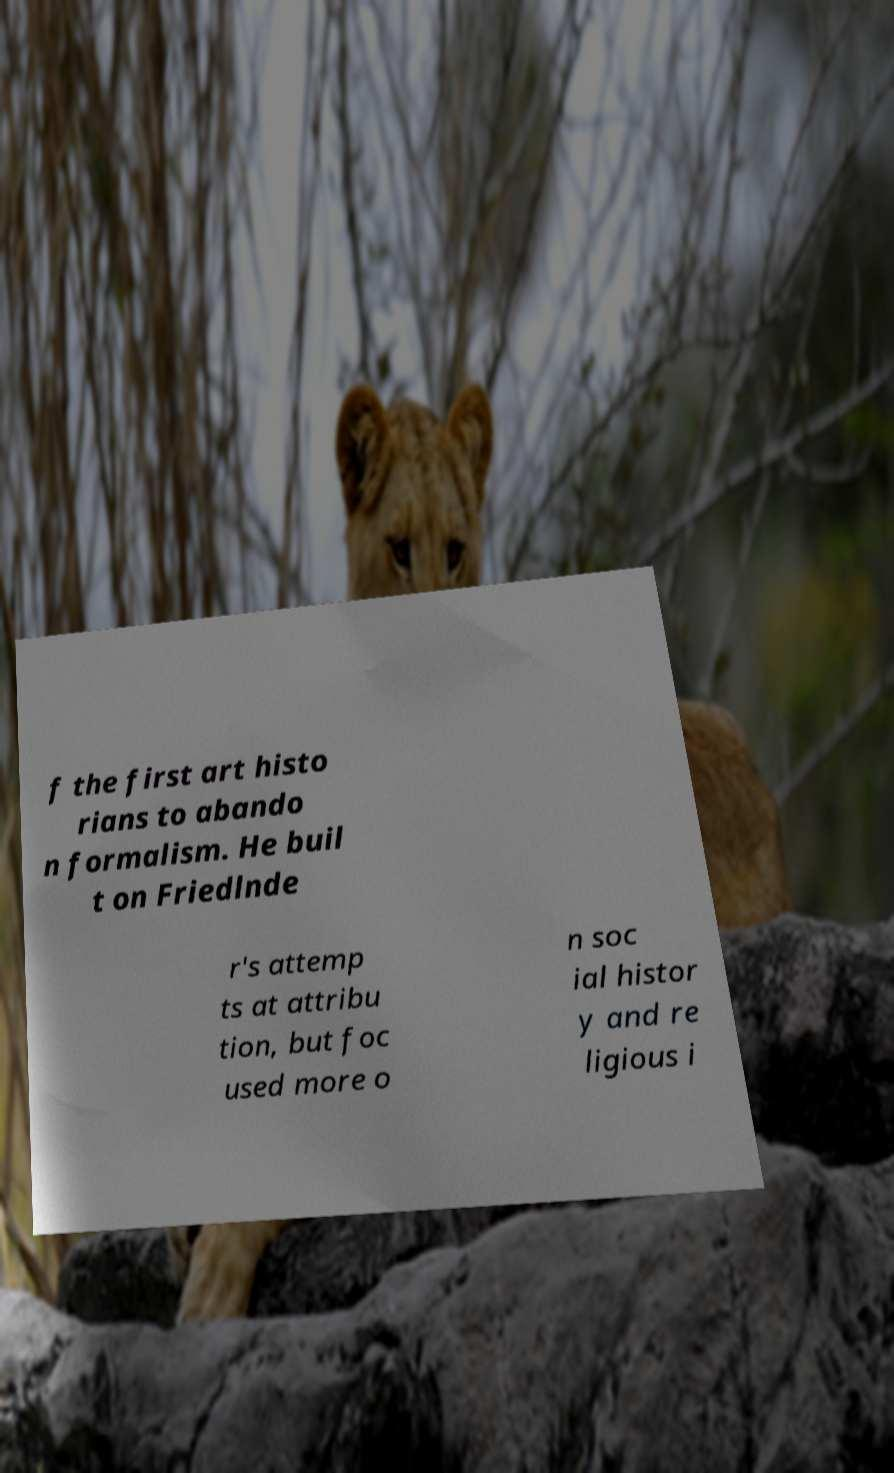Could you extract and type out the text from this image? f the first art histo rians to abando n formalism. He buil t on Friedlnde r's attemp ts at attribu tion, but foc used more o n soc ial histor y and re ligious i 